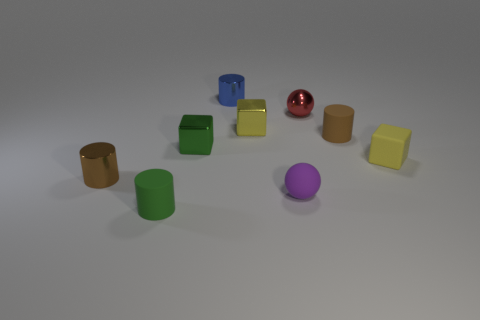Subtract 1 cylinders. How many cylinders are left? 3 Subtract all cylinders. How many objects are left? 5 Add 2 red metallic objects. How many red metallic objects are left? 3 Add 5 small green matte cylinders. How many small green matte cylinders exist? 6 Subtract 1 brown cylinders. How many objects are left? 8 Subtract all red cylinders. Subtract all purple matte things. How many objects are left? 8 